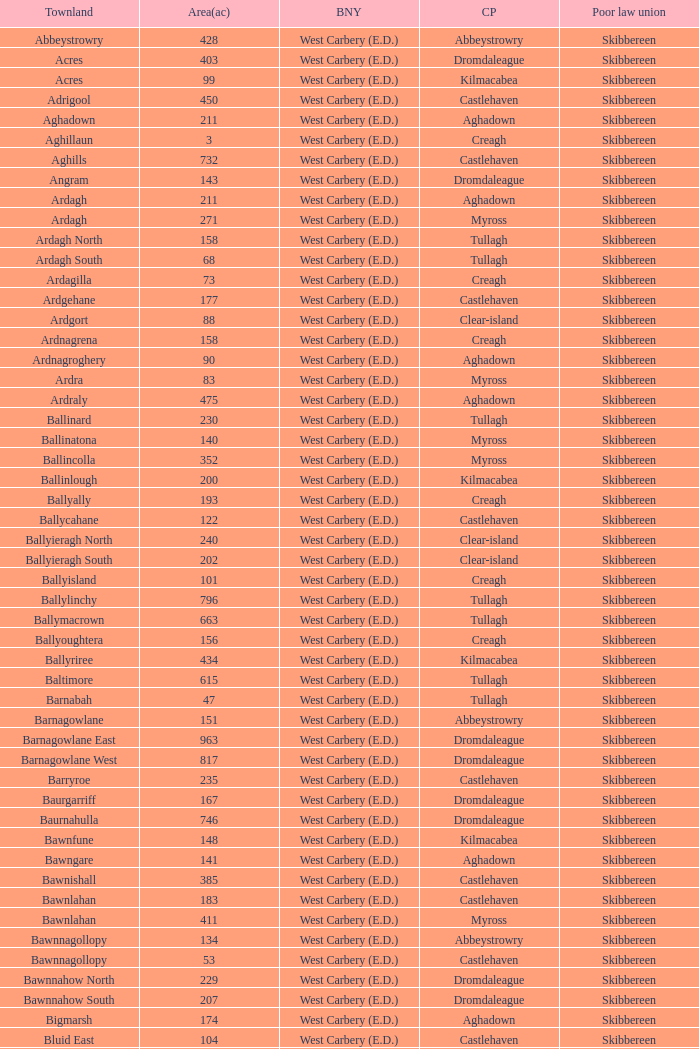What is the greatest area when the Poor Law Union is Skibbereen and the Civil Parish is Tullagh? 796.0. 